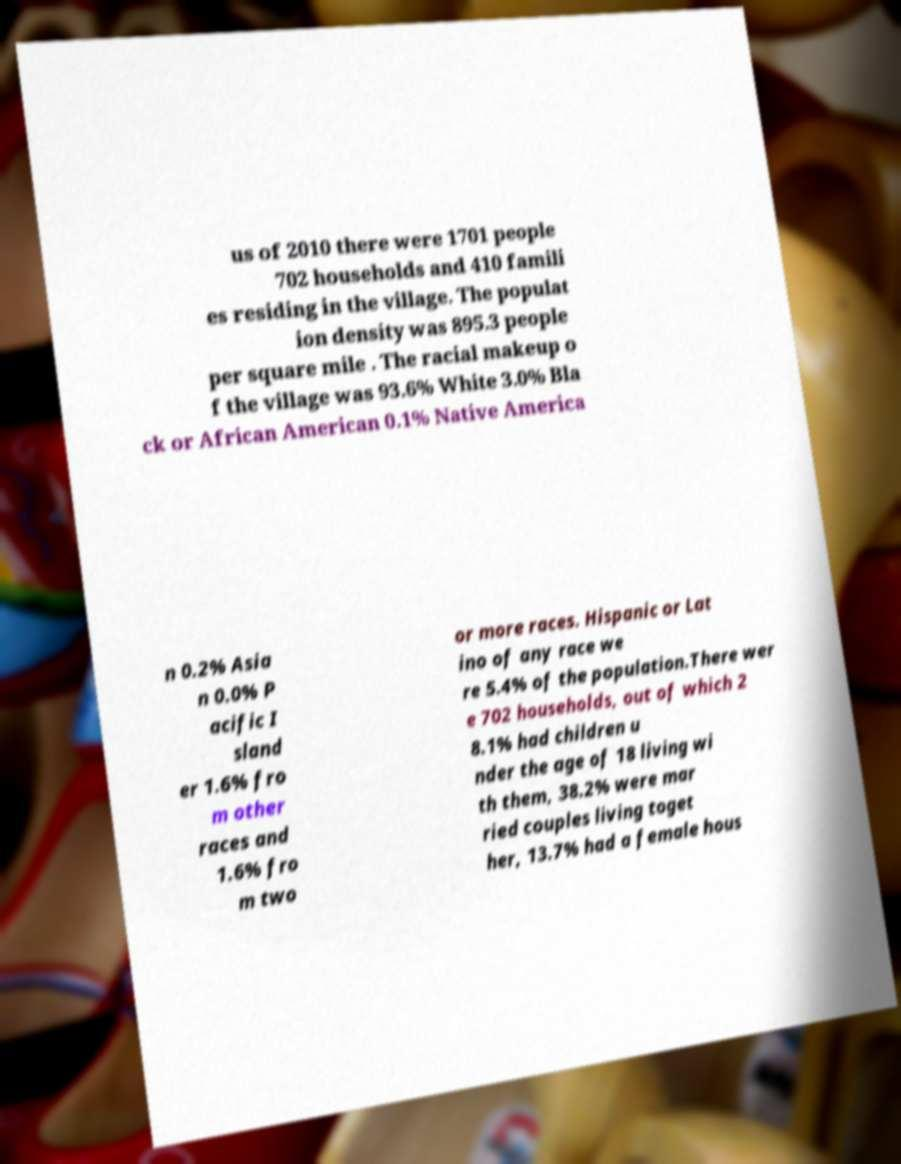Please read and relay the text visible in this image. What does it say? us of 2010 there were 1701 people 702 households and 410 famili es residing in the village. The populat ion density was 895.3 people per square mile . The racial makeup o f the village was 93.6% White 3.0% Bla ck or African American 0.1% Native America n 0.2% Asia n 0.0% P acific I sland er 1.6% fro m other races and 1.6% fro m two or more races. Hispanic or Lat ino of any race we re 5.4% of the population.There wer e 702 households, out of which 2 8.1% had children u nder the age of 18 living wi th them, 38.2% were mar ried couples living toget her, 13.7% had a female hous 